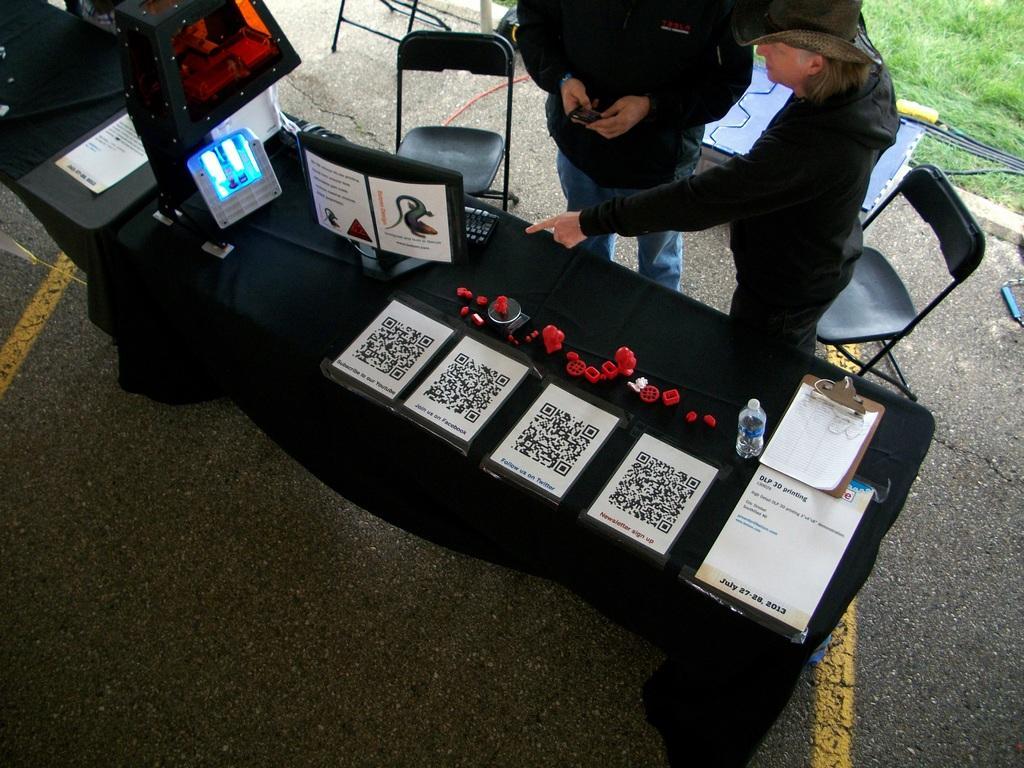Can you describe this image briefly? On the table we can see laptop, papers, bottle, pad and other objects. Here we can see chairs. Here we can see a man and other person standing near to a table. This is a road. Here we can see grass. 